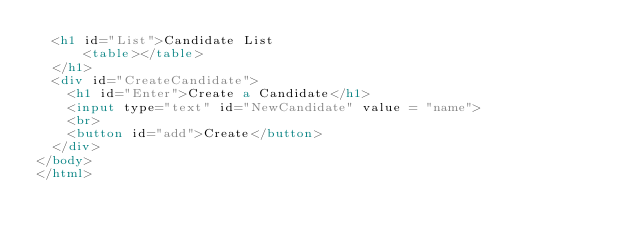<code> <loc_0><loc_0><loc_500><loc_500><_HTML_>  <h1 id="List">Candidate List
      <table></table>
  </h1>
  <div id="CreateCandidate">
    <h1 id="Enter">Create a Candidate</h1>
    <input type="text" id="NewCandidate" value = "name">
    <br>
    <button id="add">Create</button>
  </div>
</body>
</html>
</code> 